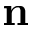<formula> <loc_0><loc_0><loc_500><loc_500>{ n }</formula> 